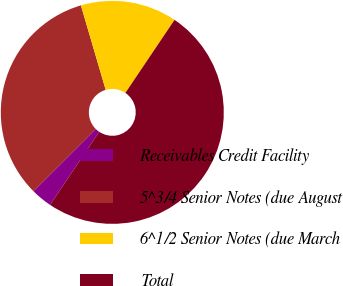<chart> <loc_0><loc_0><loc_500><loc_500><pie_chart><fcel>Receivables Credit Facility<fcel>5^3/4 Senior Notes (due August<fcel>6^1/2 Senior Notes (due March<fcel>Total<nl><fcel>3.08%<fcel>32.95%<fcel>13.97%<fcel>50.0%<nl></chart> 